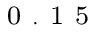Convert formula to latex. <formula><loc_0><loc_0><loc_500><loc_500>_ { 0 } . 1 5</formula> 